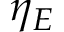Convert formula to latex. <formula><loc_0><loc_0><loc_500><loc_500>\eta _ { E }</formula> 